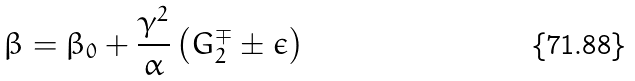<formula> <loc_0><loc_0><loc_500><loc_500>\beta = \beta _ { 0 } + \frac { \gamma ^ { 2 } } { \alpha } \left ( G _ { 2 } ^ { \mp } \pm \epsilon \right )</formula> 